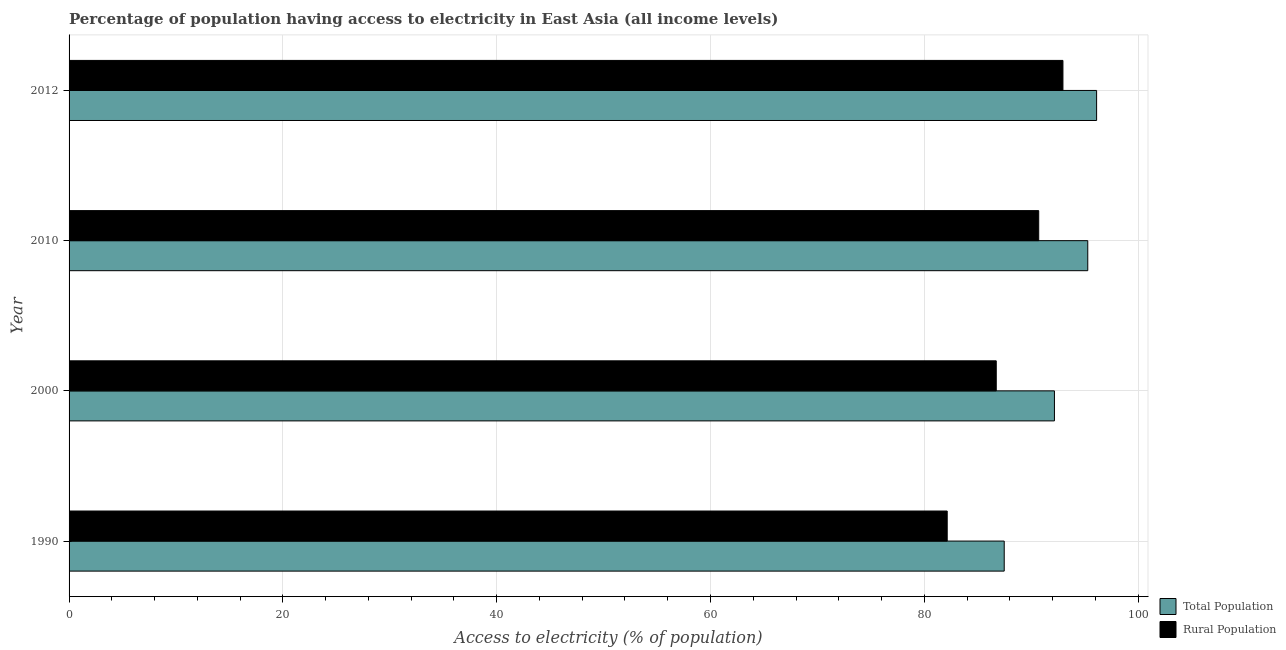How many different coloured bars are there?
Provide a short and direct response. 2. How many groups of bars are there?
Make the answer very short. 4. Are the number of bars per tick equal to the number of legend labels?
Offer a very short reply. Yes. Are the number of bars on each tick of the Y-axis equal?
Provide a short and direct response. Yes. What is the label of the 3rd group of bars from the top?
Offer a very short reply. 2000. What is the percentage of population having access to electricity in 1990?
Make the answer very short. 87.48. Across all years, what is the maximum percentage of population having access to electricity?
Provide a short and direct response. 96.12. Across all years, what is the minimum percentage of rural population having access to electricity?
Provide a short and direct response. 82.14. In which year was the percentage of rural population having access to electricity maximum?
Your answer should be compact. 2012. In which year was the percentage of rural population having access to electricity minimum?
Your answer should be compact. 1990. What is the total percentage of population having access to electricity in the graph?
Ensure brevity in your answer.  371.06. What is the difference between the percentage of rural population having access to electricity in 1990 and that in 2012?
Make the answer very short. -10.83. What is the difference between the percentage of population having access to electricity in 2012 and the percentage of rural population having access to electricity in 1990?
Ensure brevity in your answer.  13.98. What is the average percentage of population having access to electricity per year?
Offer a very short reply. 92.76. In the year 1990, what is the difference between the percentage of rural population having access to electricity and percentage of population having access to electricity?
Keep it short and to the point. -5.33. What is the ratio of the percentage of population having access to electricity in 1990 to that in 2012?
Make the answer very short. 0.91. Is the percentage of rural population having access to electricity in 1990 less than that in 2012?
Provide a short and direct response. Yes. Is the difference between the percentage of rural population having access to electricity in 1990 and 2012 greater than the difference between the percentage of population having access to electricity in 1990 and 2012?
Your answer should be very brief. No. What is the difference between the highest and the second highest percentage of rural population having access to electricity?
Provide a succinct answer. 2.27. What is the difference between the highest and the lowest percentage of rural population having access to electricity?
Ensure brevity in your answer.  10.83. What does the 1st bar from the top in 2000 represents?
Provide a succinct answer. Rural Population. What does the 2nd bar from the bottom in 2000 represents?
Your answer should be very brief. Rural Population. Are all the bars in the graph horizontal?
Keep it short and to the point. Yes. Where does the legend appear in the graph?
Provide a short and direct response. Bottom right. How many legend labels are there?
Keep it short and to the point. 2. What is the title of the graph?
Keep it short and to the point. Percentage of population having access to electricity in East Asia (all income levels). Does "IMF nonconcessional" appear as one of the legend labels in the graph?
Your answer should be compact. No. What is the label or title of the X-axis?
Offer a terse response. Access to electricity (% of population). What is the Access to electricity (% of population) in Total Population in 1990?
Your response must be concise. 87.48. What is the Access to electricity (% of population) of Rural Population in 1990?
Give a very brief answer. 82.14. What is the Access to electricity (% of population) in Total Population in 2000?
Your answer should be very brief. 92.17. What is the Access to electricity (% of population) in Rural Population in 2000?
Make the answer very short. 86.73. What is the Access to electricity (% of population) of Total Population in 2010?
Offer a terse response. 95.29. What is the Access to electricity (% of population) of Rural Population in 2010?
Make the answer very short. 90.7. What is the Access to electricity (% of population) in Total Population in 2012?
Offer a terse response. 96.12. What is the Access to electricity (% of population) in Rural Population in 2012?
Your answer should be compact. 92.97. Across all years, what is the maximum Access to electricity (% of population) in Total Population?
Offer a terse response. 96.12. Across all years, what is the maximum Access to electricity (% of population) in Rural Population?
Your answer should be very brief. 92.97. Across all years, what is the minimum Access to electricity (% of population) of Total Population?
Ensure brevity in your answer.  87.48. Across all years, what is the minimum Access to electricity (% of population) of Rural Population?
Keep it short and to the point. 82.14. What is the total Access to electricity (% of population) in Total Population in the graph?
Provide a succinct answer. 371.06. What is the total Access to electricity (% of population) in Rural Population in the graph?
Ensure brevity in your answer.  352.54. What is the difference between the Access to electricity (% of population) of Total Population in 1990 and that in 2000?
Your response must be concise. -4.7. What is the difference between the Access to electricity (% of population) in Rural Population in 1990 and that in 2000?
Offer a very short reply. -4.59. What is the difference between the Access to electricity (% of population) of Total Population in 1990 and that in 2010?
Give a very brief answer. -7.82. What is the difference between the Access to electricity (% of population) of Rural Population in 1990 and that in 2010?
Provide a short and direct response. -8.56. What is the difference between the Access to electricity (% of population) of Total Population in 1990 and that in 2012?
Provide a succinct answer. -8.64. What is the difference between the Access to electricity (% of population) in Rural Population in 1990 and that in 2012?
Your answer should be very brief. -10.83. What is the difference between the Access to electricity (% of population) in Total Population in 2000 and that in 2010?
Provide a succinct answer. -3.12. What is the difference between the Access to electricity (% of population) of Rural Population in 2000 and that in 2010?
Make the answer very short. -3.97. What is the difference between the Access to electricity (% of population) of Total Population in 2000 and that in 2012?
Your answer should be compact. -3.95. What is the difference between the Access to electricity (% of population) in Rural Population in 2000 and that in 2012?
Your answer should be very brief. -6.24. What is the difference between the Access to electricity (% of population) in Total Population in 2010 and that in 2012?
Your answer should be compact. -0.83. What is the difference between the Access to electricity (% of population) of Rural Population in 2010 and that in 2012?
Provide a short and direct response. -2.27. What is the difference between the Access to electricity (% of population) in Total Population in 1990 and the Access to electricity (% of population) in Rural Population in 2000?
Your response must be concise. 0.74. What is the difference between the Access to electricity (% of population) of Total Population in 1990 and the Access to electricity (% of population) of Rural Population in 2010?
Your answer should be compact. -3.23. What is the difference between the Access to electricity (% of population) in Total Population in 1990 and the Access to electricity (% of population) in Rural Population in 2012?
Give a very brief answer. -5.49. What is the difference between the Access to electricity (% of population) in Total Population in 2000 and the Access to electricity (% of population) in Rural Population in 2010?
Give a very brief answer. 1.47. What is the difference between the Access to electricity (% of population) in Total Population in 2000 and the Access to electricity (% of population) in Rural Population in 2012?
Your answer should be very brief. -0.79. What is the difference between the Access to electricity (% of population) of Total Population in 2010 and the Access to electricity (% of population) of Rural Population in 2012?
Give a very brief answer. 2.32. What is the average Access to electricity (% of population) in Total Population per year?
Make the answer very short. 92.76. What is the average Access to electricity (% of population) in Rural Population per year?
Your response must be concise. 88.14. In the year 1990, what is the difference between the Access to electricity (% of population) of Total Population and Access to electricity (% of population) of Rural Population?
Keep it short and to the point. 5.33. In the year 2000, what is the difference between the Access to electricity (% of population) of Total Population and Access to electricity (% of population) of Rural Population?
Offer a very short reply. 5.44. In the year 2010, what is the difference between the Access to electricity (% of population) in Total Population and Access to electricity (% of population) in Rural Population?
Offer a terse response. 4.59. In the year 2012, what is the difference between the Access to electricity (% of population) of Total Population and Access to electricity (% of population) of Rural Population?
Keep it short and to the point. 3.15. What is the ratio of the Access to electricity (% of population) in Total Population in 1990 to that in 2000?
Offer a very short reply. 0.95. What is the ratio of the Access to electricity (% of population) in Rural Population in 1990 to that in 2000?
Give a very brief answer. 0.95. What is the ratio of the Access to electricity (% of population) of Total Population in 1990 to that in 2010?
Keep it short and to the point. 0.92. What is the ratio of the Access to electricity (% of population) of Rural Population in 1990 to that in 2010?
Give a very brief answer. 0.91. What is the ratio of the Access to electricity (% of population) in Total Population in 1990 to that in 2012?
Provide a succinct answer. 0.91. What is the ratio of the Access to electricity (% of population) in Rural Population in 1990 to that in 2012?
Make the answer very short. 0.88. What is the ratio of the Access to electricity (% of population) in Total Population in 2000 to that in 2010?
Provide a succinct answer. 0.97. What is the ratio of the Access to electricity (% of population) of Rural Population in 2000 to that in 2010?
Keep it short and to the point. 0.96. What is the ratio of the Access to electricity (% of population) of Total Population in 2000 to that in 2012?
Offer a very short reply. 0.96. What is the ratio of the Access to electricity (% of population) of Rural Population in 2000 to that in 2012?
Offer a terse response. 0.93. What is the ratio of the Access to electricity (% of population) of Rural Population in 2010 to that in 2012?
Ensure brevity in your answer.  0.98. What is the difference between the highest and the second highest Access to electricity (% of population) of Total Population?
Offer a terse response. 0.83. What is the difference between the highest and the second highest Access to electricity (% of population) of Rural Population?
Your answer should be very brief. 2.27. What is the difference between the highest and the lowest Access to electricity (% of population) of Total Population?
Keep it short and to the point. 8.64. What is the difference between the highest and the lowest Access to electricity (% of population) of Rural Population?
Your response must be concise. 10.83. 